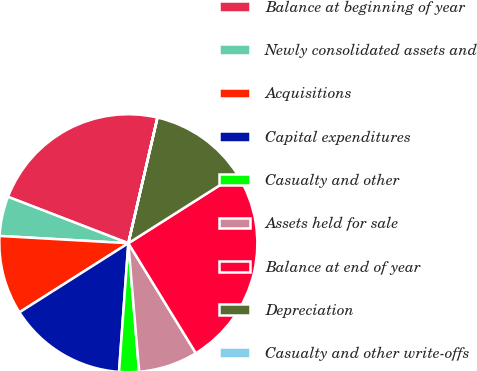<chart> <loc_0><loc_0><loc_500><loc_500><pie_chart><fcel>Balance at beginning of year<fcel>Newly consolidated assets and<fcel>Acquisitions<fcel>Capital expenditures<fcel>Casualty and other<fcel>Assets held for sale<fcel>Balance at end of year<fcel>Depreciation<fcel>Casualty and other write-offs<nl><fcel>22.76%<fcel>4.96%<fcel>9.9%<fcel>14.85%<fcel>2.49%<fcel>7.43%<fcel>25.23%<fcel>12.38%<fcel>0.01%<nl></chart> 